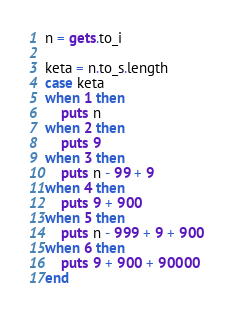<code> <loc_0><loc_0><loc_500><loc_500><_Ruby_>n = gets.to_i

keta = n.to_s.length
case keta
when 1 then
    puts n
when 2 then
    puts 9
when 3 then
    puts n - 99 + 9 
when 4 then
    puts 9 + 900
when 5 then
    puts n - 999 + 9 + 900
when 6 then
    puts 9 + 900 + 90000
end</code> 